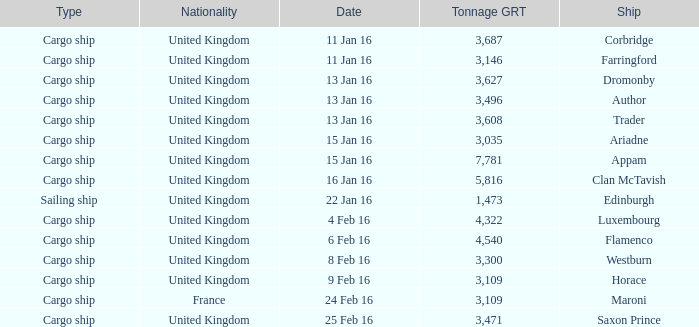What is the nationality of the ship appam? United Kingdom. 